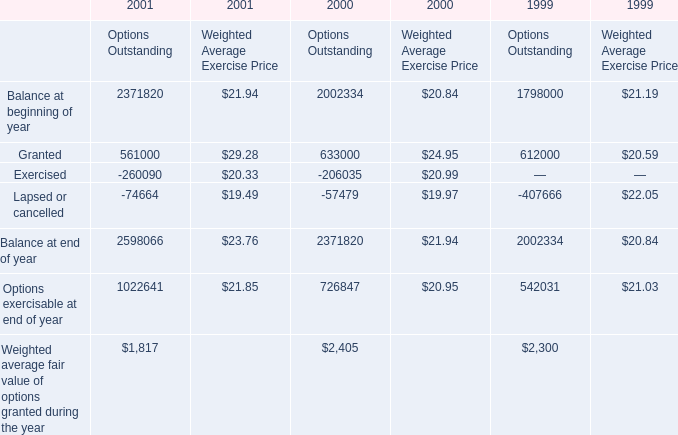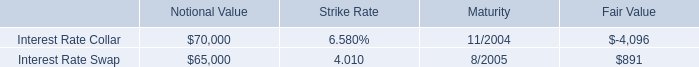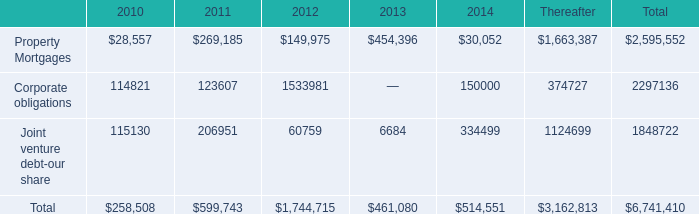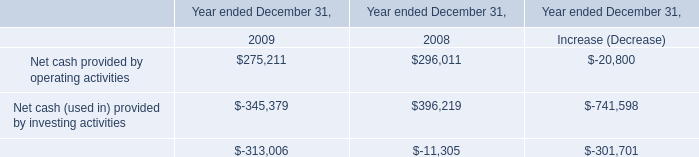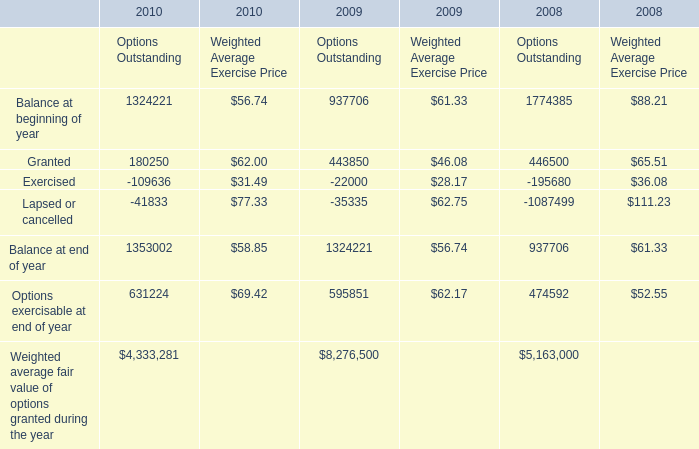what was the average total revenue in 1999 , 2000 and 2001? 
Computations: (((257685 + 230323) + 206017) / 3)
Answer: 231341.66667. 